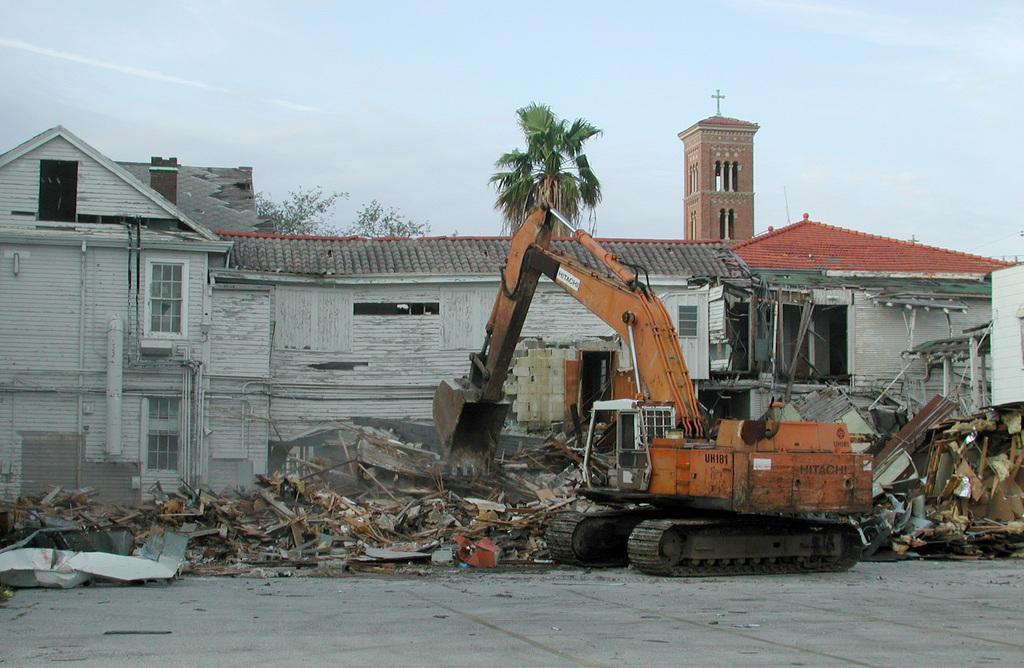Could you give a brief overview of what you see in this image? In the image there is a house and it is deconstructed by a crane, behind the house there is a tree and a church. 